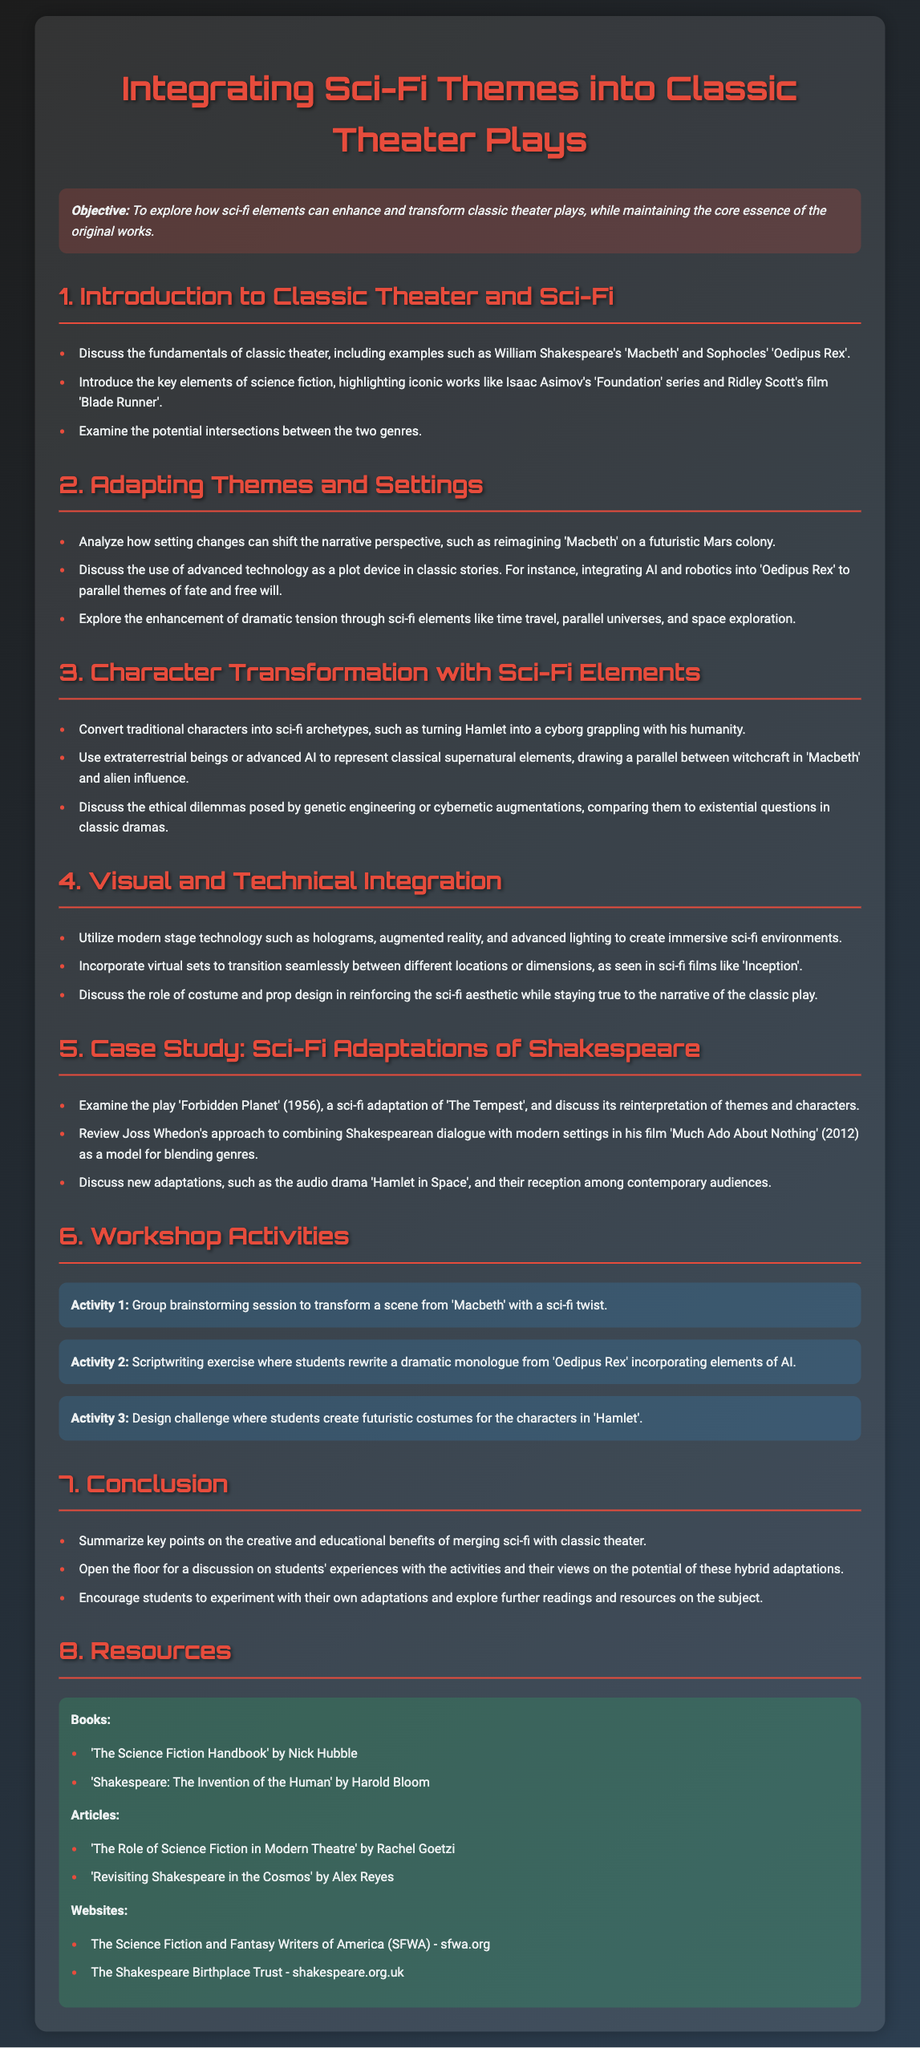What is the objective of the lesson plan? The objective is to explore how sci-fi elements can enhance and transform classic theater plays, while maintaining the core essence of the original works.
Answer: To explore how sci-fi elements can enhance and transform classic theater plays, while maintaining the core essence of the original works Which classic play is mentioned in the context of adapting themes and settings? The mentioned classic play is used as an example to discuss setting changes and narrative perspectives.
Answer: Macbeth What does Activity 1 involve? Activity 1 is a brainstorming session focused on transforming a scene with a specific twist.
Answer: Transform a scene from 'Macbeth' with a sci-fi twist Name one book listed in the resources section. The resources section contains books that can provide further insights into the integration of sci-fi and classic theater.
Answer: The Science Fiction Handbook How many activity examples are provided in the workshop activities? The number of listed activities can help gauge the variety of practical exercises included in the lesson plan.
Answer: Three What is a key element of science fiction highlighted in the introduction? Understanding key elements of science fiction is crucial for exploring its intersection with classic theater.
Answer: Iconic works like Isaac Asimov's 'Foundation' series and Ridley Scott's film 'Blade Runner' What is the role of costume and prop design according to the document? The document discusses the importance of costume and prop design in supporting the visual theme of the adaptation.
Answer: Reinforcing the sci-fi aesthetic while staying true to the narrative Which case study focuses on a sci-fi adaptation of Shakespeare? Identifying case studies reveals examples of successful genre blending and adaptation.
Answer: Forbidden Planet (1956) 